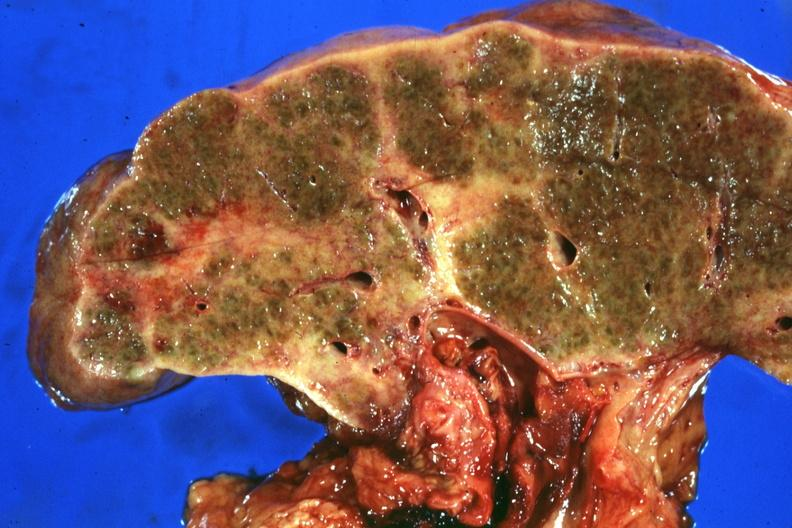s there present?
Answer the question using a single word or phrase. No 